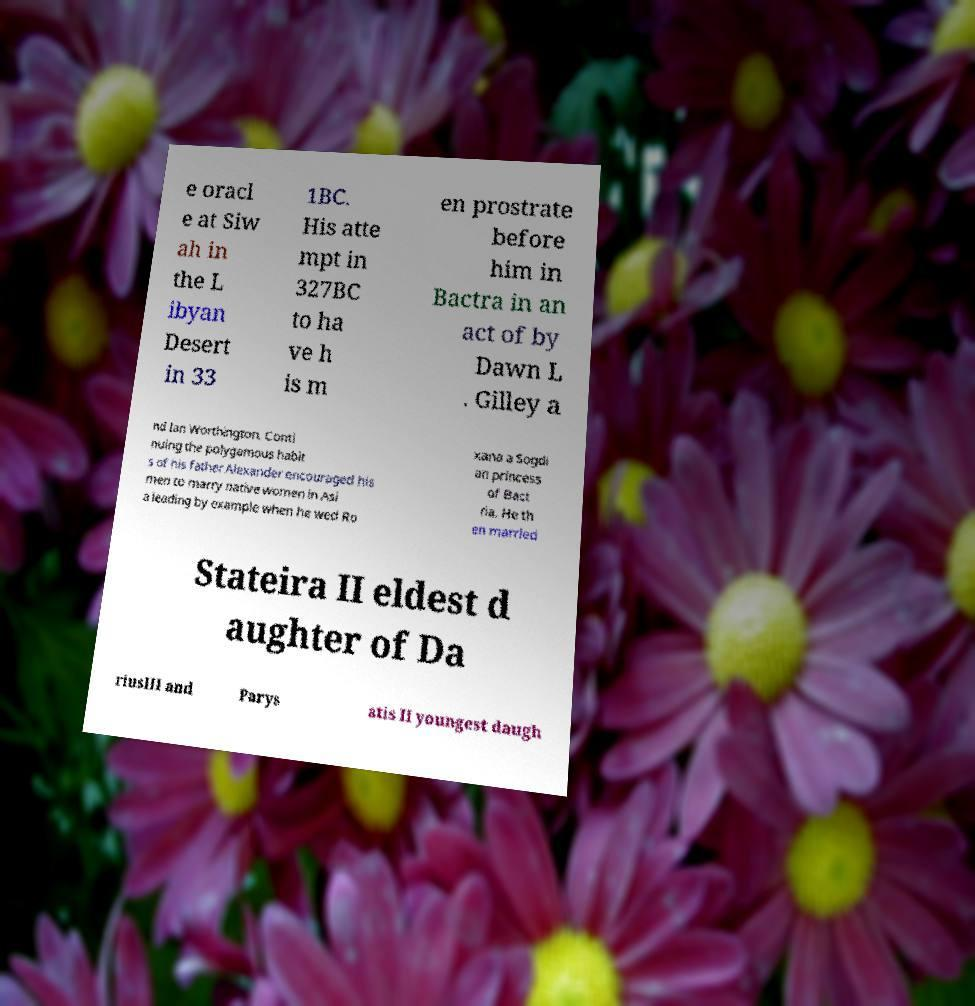I need the written content from this picture converted into text. Can you do that? e oracl e at Siw ah in the L ibyan Desert in 33 1BC. His atte mpt in 327BC to ha ve h is m en prostrate before him in Bactra in an act of by Dawn L . Gilley a nd Ian Worthington. Conti nuing the polygamous habit s of his father Alexander encouraged his men to marry native women in Asi a leading by example when he wed Ro xana a Sogdi an princess of Bact ria. He th en married Stateira II eldest d aughter of Da riusIII and Parys atis II youngest daugh 